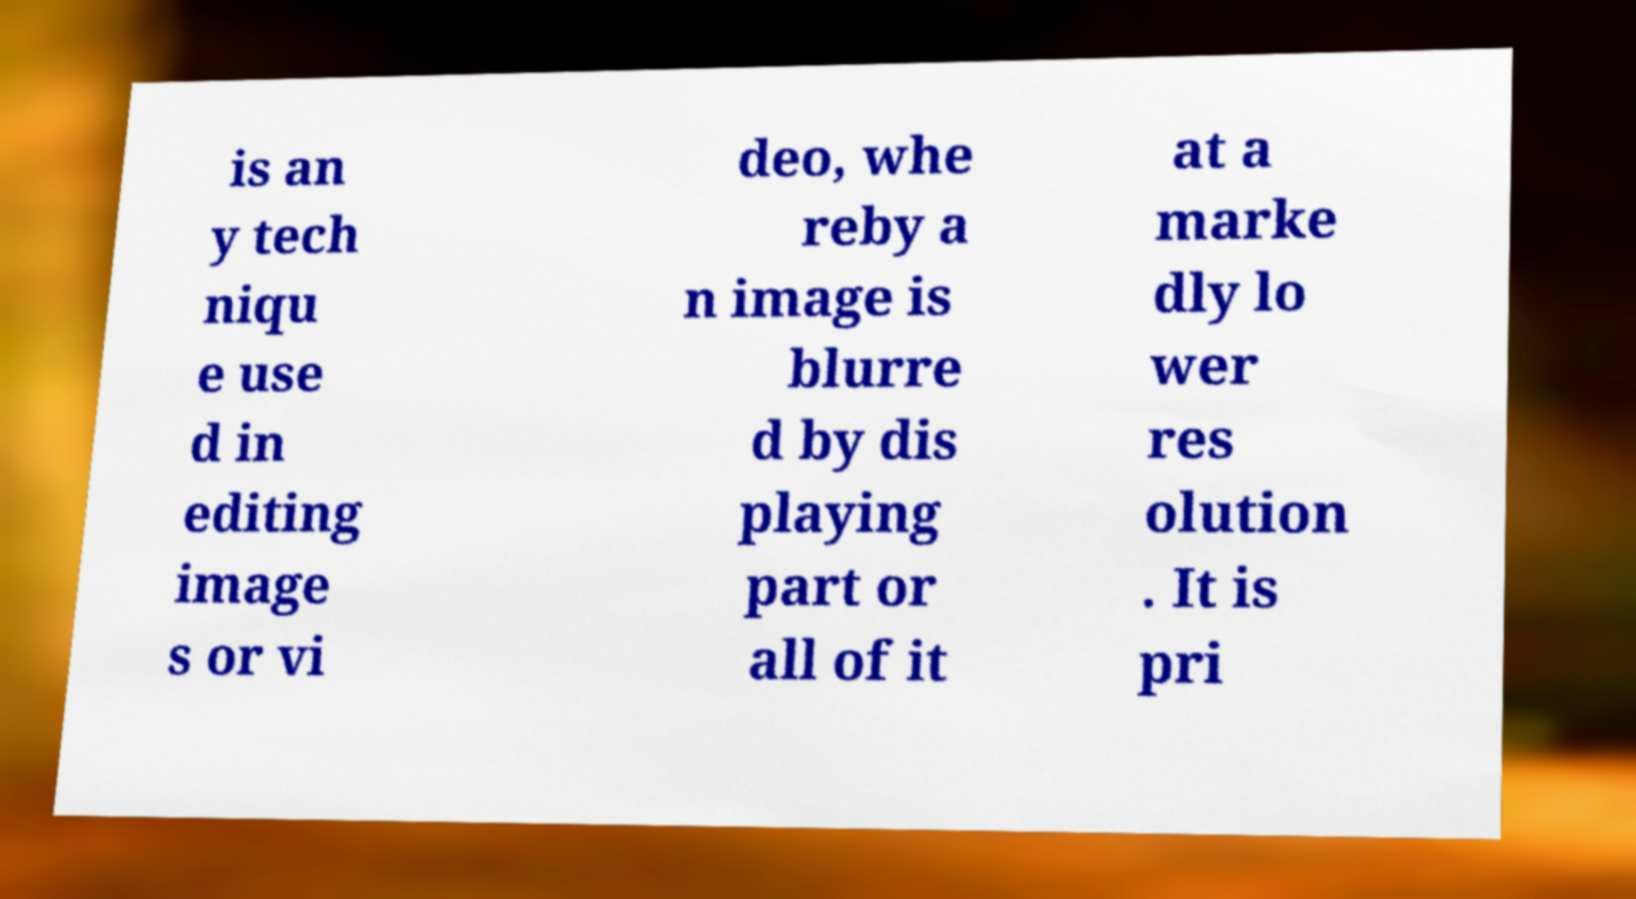Please read and relay the text visible in this image. What does it say? is an y tech niqu e use d in editing image s or vi deo, whe reby a n image is blurre d by dis playing part or all of it at a marke dly lo wer res olution . It is pri 